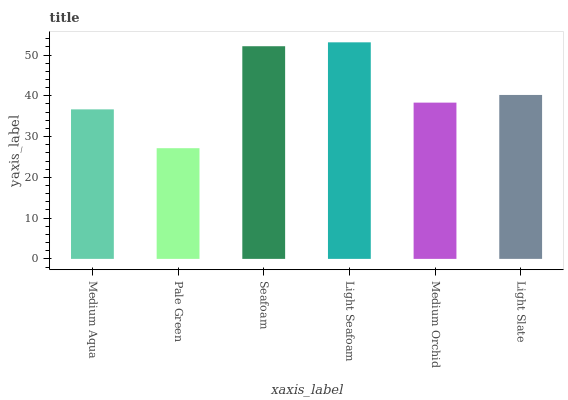Is Pale Green the minimum?
Answer yes or no. Yes. Is Light Seafoam the maximum?
Answer yes or no. Yes. Is Seafoam the minimum?
Answer yes or no. No. Is Seafoam the maximum?
Answer yes or no. No. Is Seafoam greater than Pale Green?
Answer yes or no. Yes. Is Pale Green less than Seafoam?
Answer yes or no. Yes. Is Pale Green greater than Seafoam?
Answer yes or no. No. Is Seafoam less than Pale Green?
Answer yes or no. No. Is Light Slate the high median?
Answer yes or no. Yes. Is Medium Orchid the low median?
Answer yes or no. Yes. Is Light Seafoam the high median?
Answer yes or no. No. Is Light Seafoam the low median?
Answer yes or no. No. 